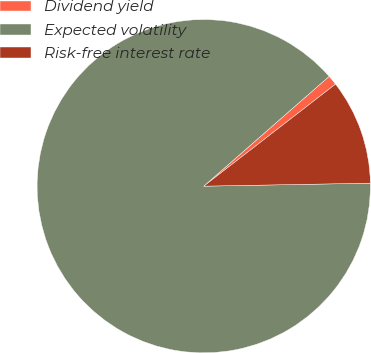Convert chart. <chart><loc_0><loc_0><loc_500><loc_500><pie_chart><fcel>Dividend yield<fcel>Expected volatility<fcel>Risk-free interest rate<nl><fcel>0.96%<fcel>88.83%<fcel>10.2%<nl></chart> 